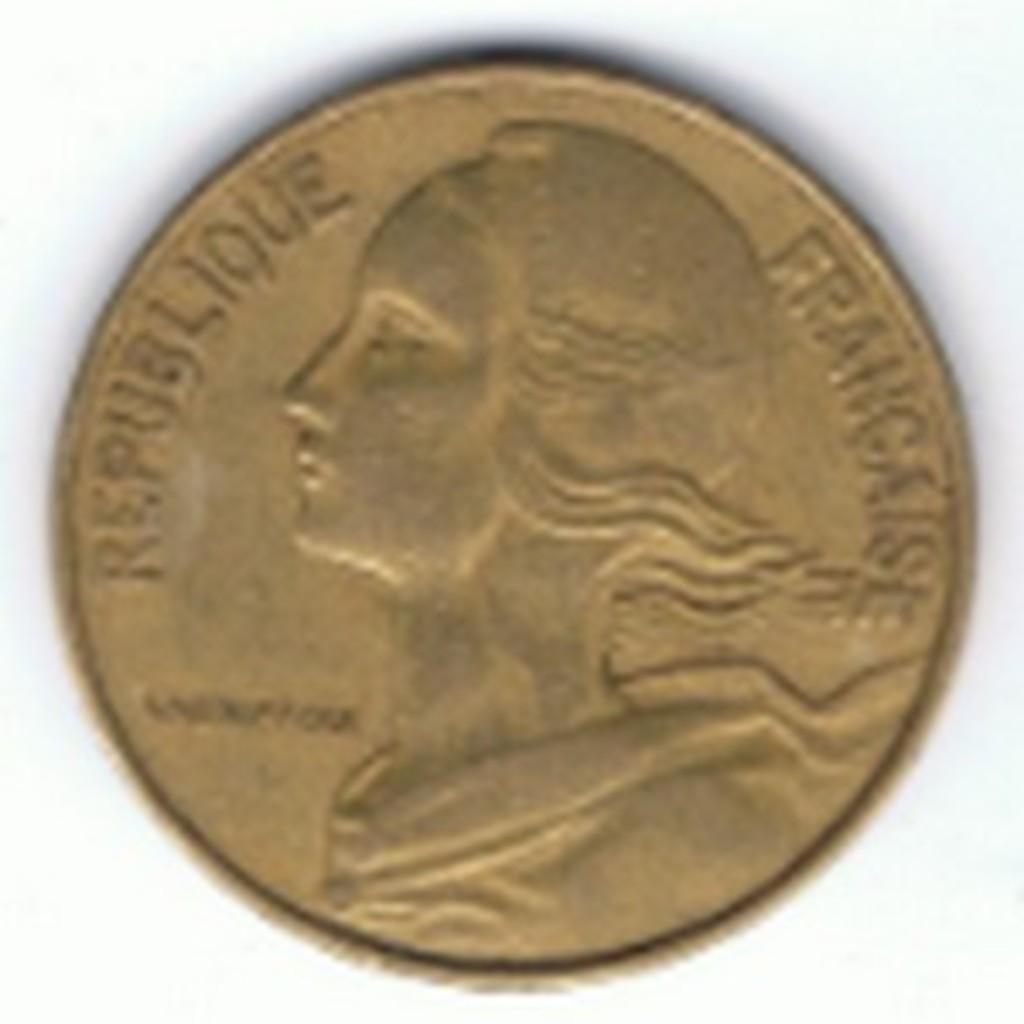What nationality is this currency?
Your answer should be compact. France. 